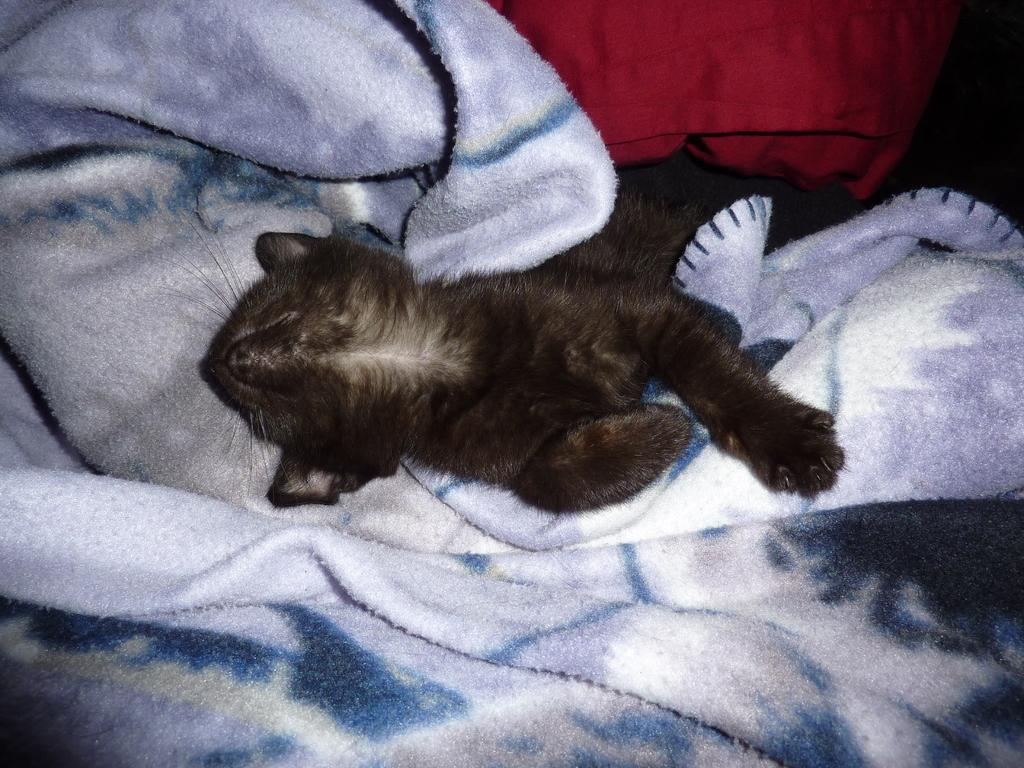What type of creature is present in the image? There is an animal in the image. Where is the animal located? The animal is on a blanket. How many girls are playing with the animal on the blanket in the image? There is no mention of girls or any other people in the image; it only features an animal on a blanket. 